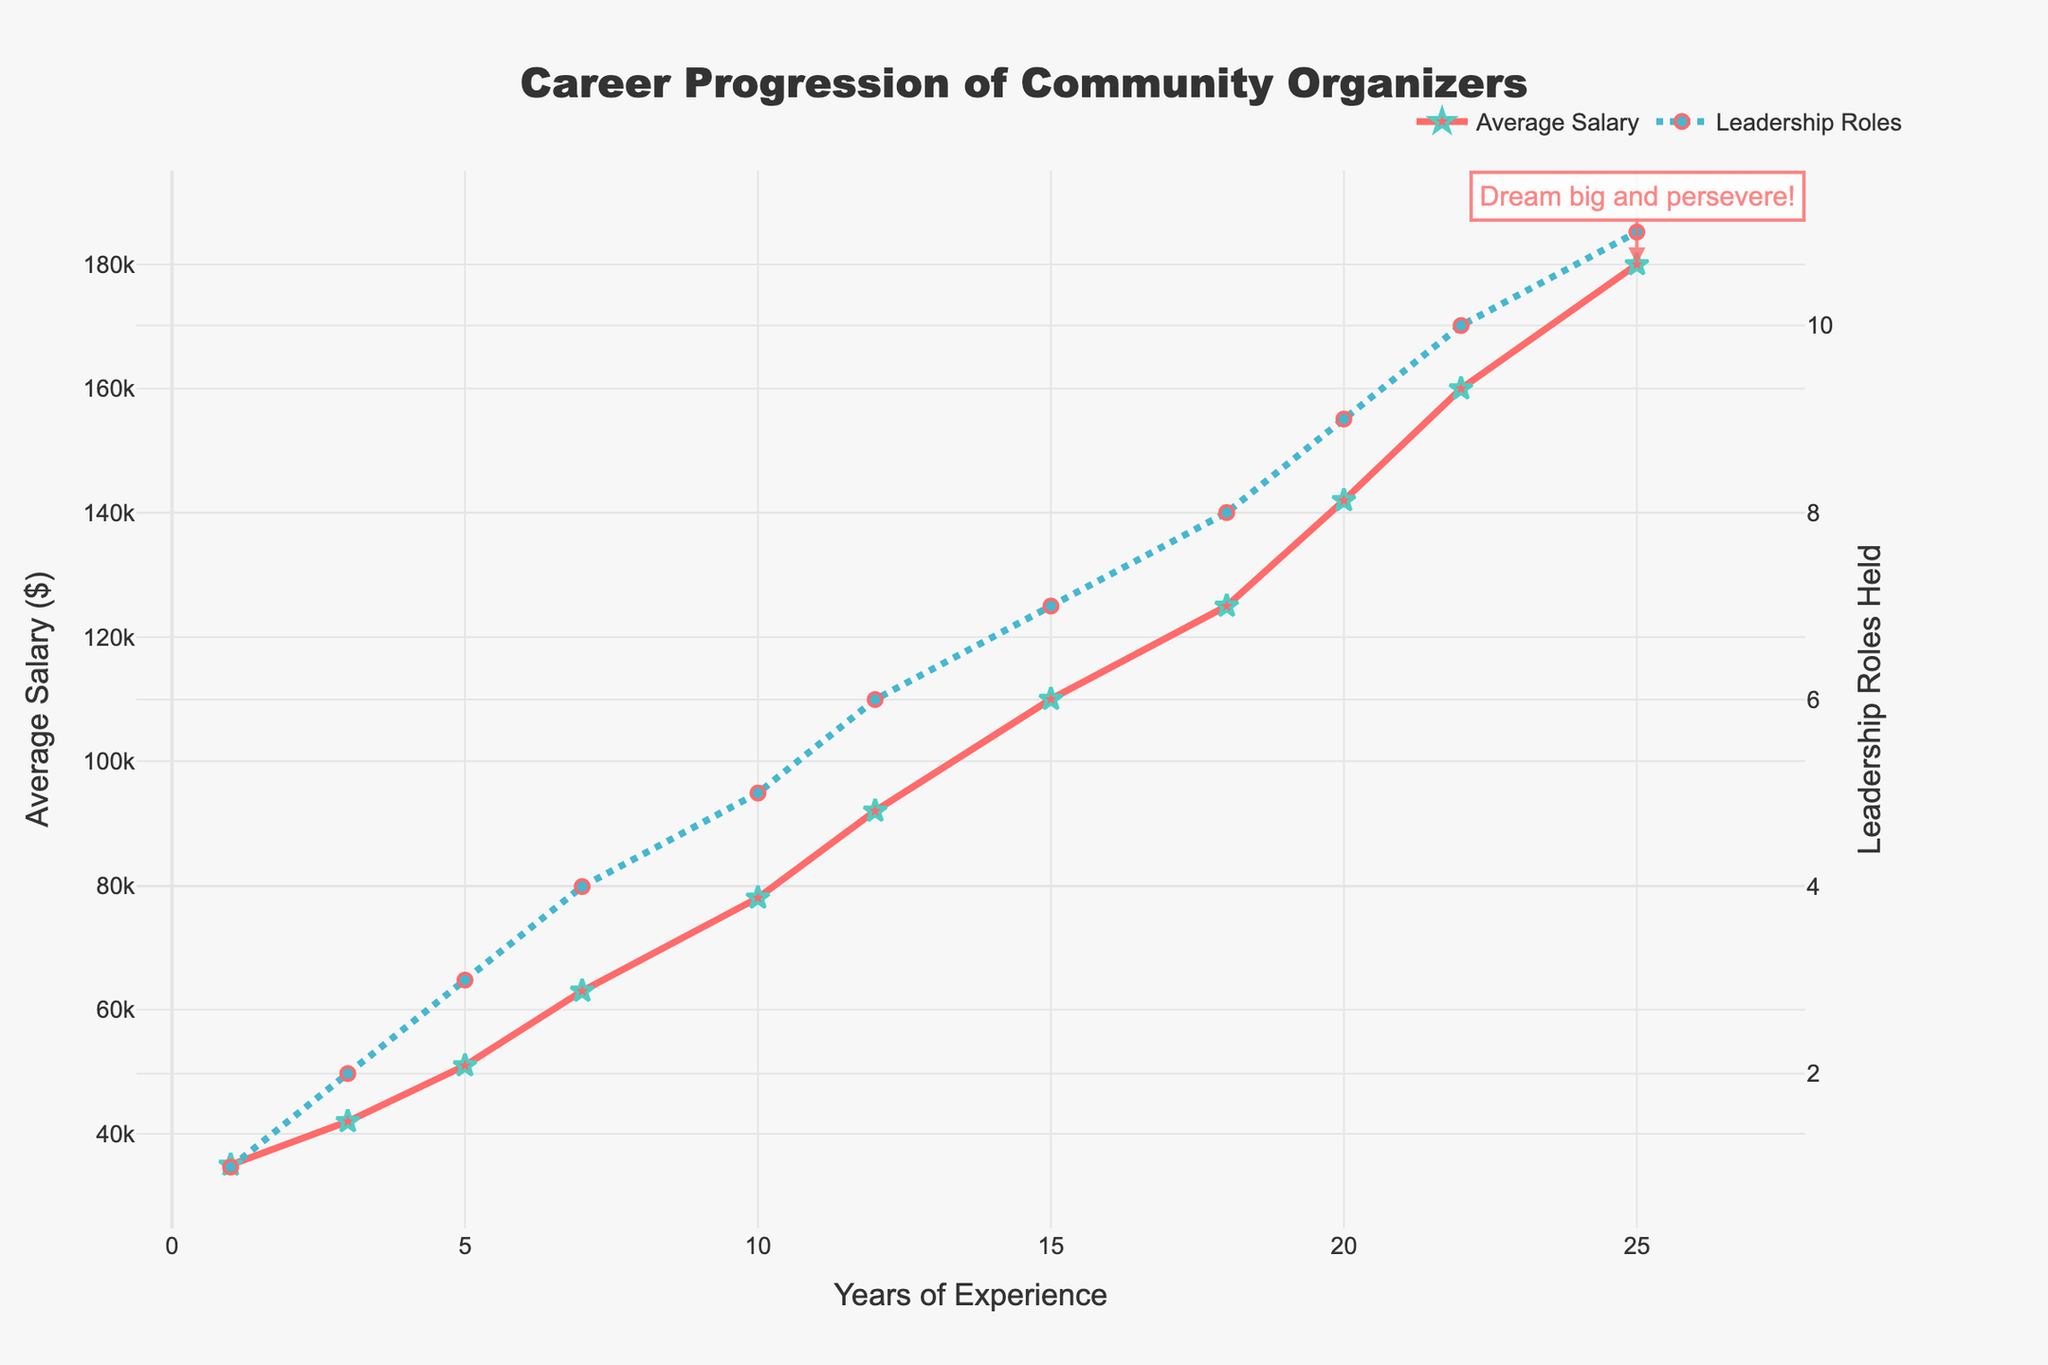What's the average salary by the 10th year compared to the 5th year? First, locate the salaries for the 5th and 10th years on the x-axis. The salary in the 5th year is $51,000, and in the 10th year it is $78,000. Then, calculate the average by summing these values and dividing by 2: (51000 + 78000) / 2 = $64,500.
Answer: $64,500 What is the salary increase from the 1st year to the 7th year? Identify the salaries for the 1st and 7th years on the x-axis. The salary in the 1st year is $35,000 and in the 7th year it is $63,000. Calculate the difference: $63,000 - $35,000 = $28,000.
Answer: $28,000 How many leadership roles are held by the 12th year, and how much does the salary increase from the 15th to the 18th year? First, locate the leadership roles held in the 12th year, which is 6. Then, find the salaries in the 15th year ($110,000) and the 18th year ($125,000) and calculate the difference: $125,000 - $110,000 = $15,000.
Answer: 6, $15,000 Between which years does the steepest salary increase occur? Visually inspect the slope of the "Average Salary" line. The steepest increase appears between the 18th year ($125,000) and the 20th year ($142,000). The difference is $142,000 - $125,000 = $17,000 in 2 years.
Answer: Between 18 and 20 years How does the number of leadership roles after 20 years compare to those held after 12 years? Look at the "Leadership Roles Held" line. At 12 years, there are 6 leadership roles held. By 20 years, there are 9 leadership roles. Compare the two values: 9 roles - 6 roles = 3.
Answer: 3 more roles 